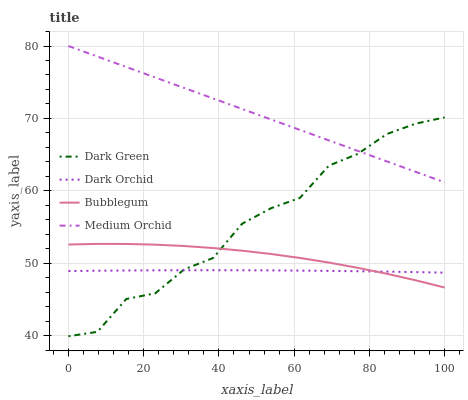Does Dark Orchid have the minimum area under the curve?
Answer yes or no. Yes. Does Medium Orchid have the maximum area under the curve?
Answer yes or no. Yes. Does Bubblegum have the minimum area under the curve?
Answer yes or no. No. Does Bubblegum have the maximum area under the curve?
Answer yes or no. No. Is Medium Orchid the smoothest?
Answer yes or no. Yes. Is Dark Green the roughest?
Answer yes or no. Yes. Is Bubblegum the smoothest?
Answer yes or no. No. Is Bubblegum the roughest?
Answer yes or no. No. Does Dark Green have the lowest value?
Answer yes or no. Yes. Does Bubblegum have the lowest value?
Answer yes or no. No. Does Medium Orchid have the highest value?
Answer yes or no. Yes. Does Bubblegum have the highest value?
Answer yes or no. No. Is Bubblegum less than Medium Orchid?
Answer yes or no. Yes. Is Medium Orchid greater than Dark Orchid?
Answer yes or no. Yes. Does Dark Green intersect Medium Orchid?
Answer yes or no. Yes. Is Dark Green less than Medium Orchid?
Answer yes or no. No. Is Dark Green greater than Medium Orchid?
Answer yes or no. No. Does Bubblegum intersect Medium Orchid?
Answer yes or no. No. 